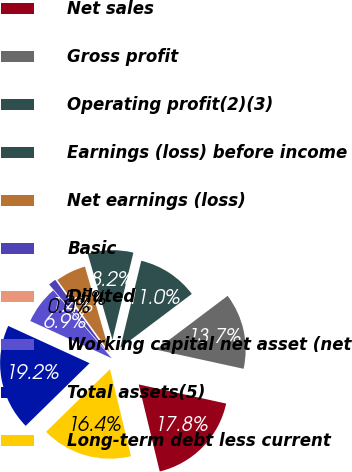Convert chart. <chart><loc_0><loc_0><loc_500><loc_500><pie_chart><fcel>Net sales<fcel>Gross profit<fcel>Operating profit(2)(3)<fcel>Earnings (loss) before income<fcel>Net earnings (loss)<fcel>Basic<fcel>Diluted<fcel>Working capital net asset (net<fcel>Total assets(5)<fcel>Long-term debt less current<nl><fcel>17.8%<fcel>13.7%<fcel>10.96%<fcel>8.22%<fcel>5.48%<fcel>1.37%<fcel>0.01%<fcel>6.85%<fcel>19.17%<fcel>16.43%<nl></chart> 